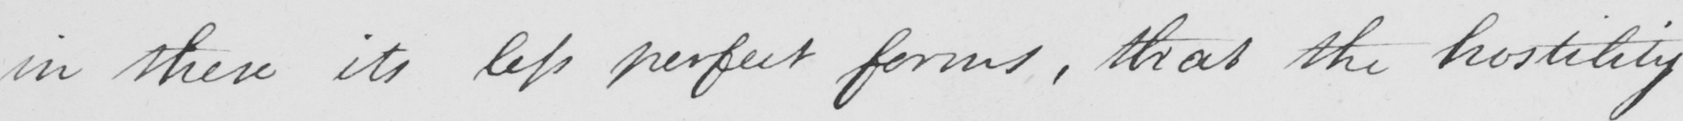Transcribe the text shown in this historical manuscript line. in these its less perfect forms , that the hostility 